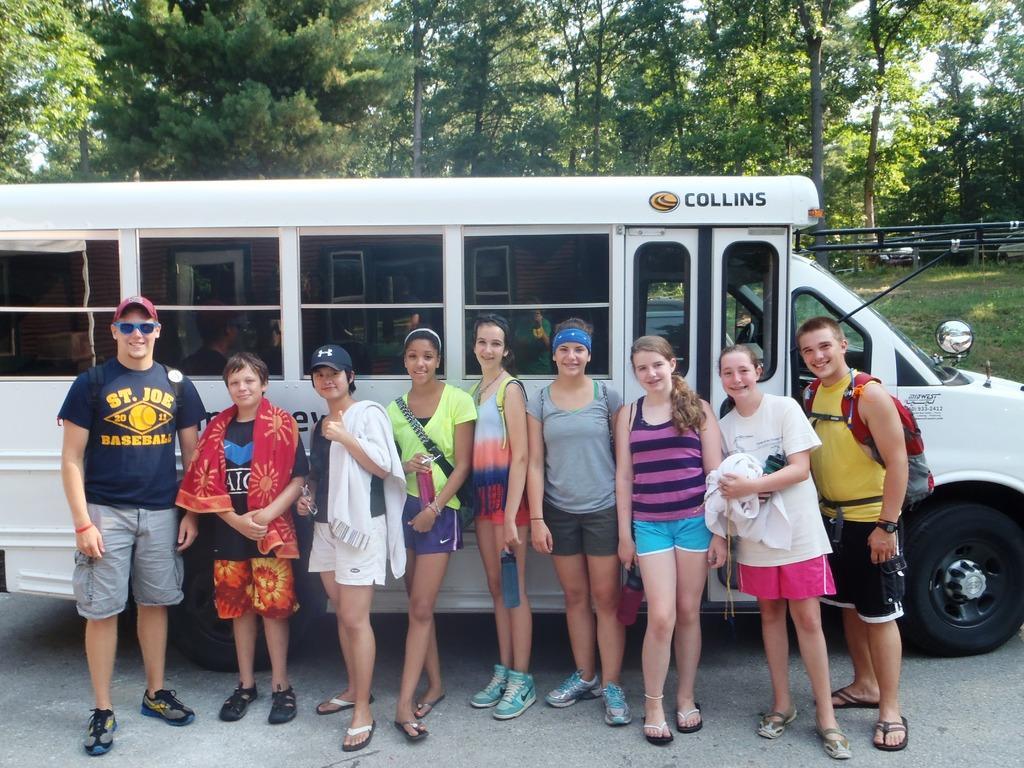How would you summarize this image in a sentence or two? In this image we can see a group of people on the road standing beside a truck. On the backside we can see a fence, grass, plants, a group of trees and the sky. 